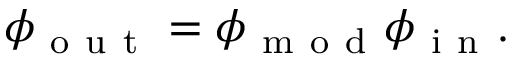Convert formula to latex. <formula><loc_0><loc_0><loc_500><loc_500>\phi _ { o u t } = \phi _ { m o d } \phi _ { i n } .</formula> 